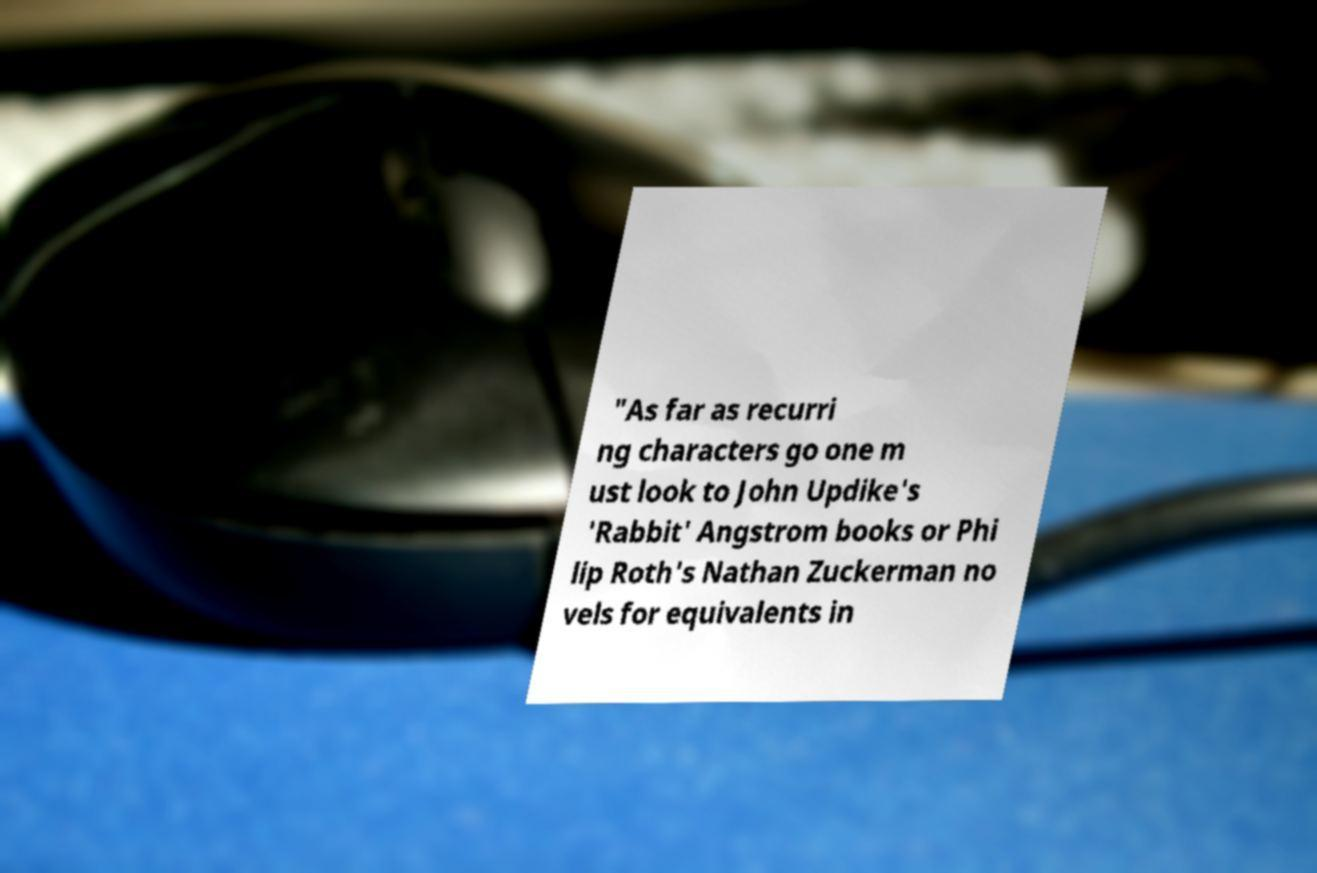Can you accurately transcribe the text from the provided image for me? "As far as recurri ng characters go one m ust look to John Updike's 'Rabbit' Angstrom books or Phi lip Roth's Nathan Zuckerman no vels for equivalents in 